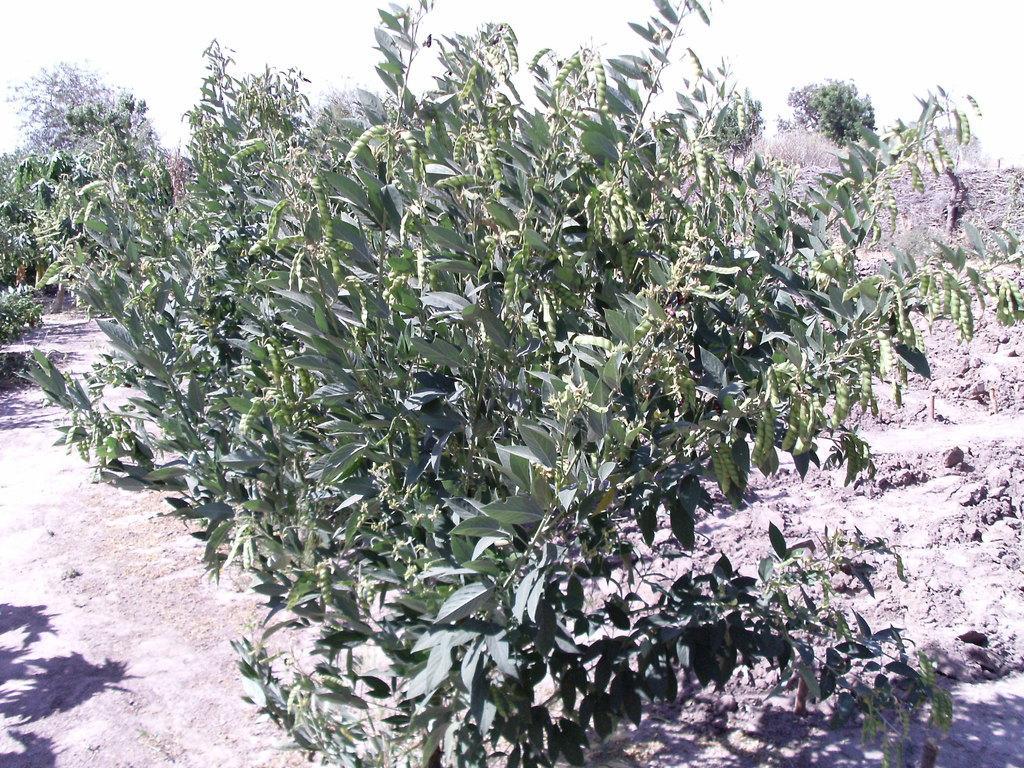Could you give a brief overview of what you see in this image? This image is taken outdoors. At the bottom of the image there is a ground. In the middle of the image there are a few trees with green leaves, stems and branches. 